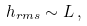<formula> <loc_0><loc_0><loc_500><loc_500>h _ { r m s } \sim L \, ,</formula> 